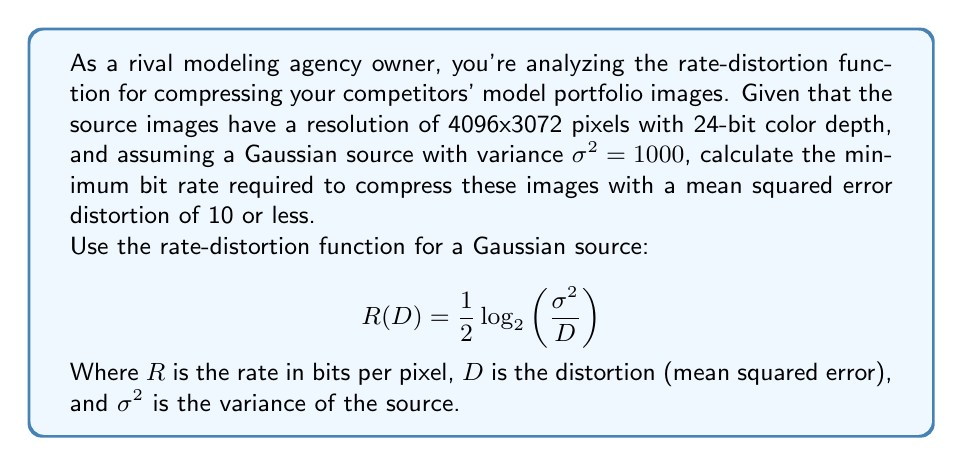What is the answer to this math problem? Let's approach this step-by-step:

1) We're given:
   - Resolution: 4096x3072 pixels
   - Color depth: 24 bits
   - Variance $\sigma^2 = 1000$
   - Desired distortion $D \leq 10$

2) The rate-distortion function for a Gaussian source is:

   $$R(D) = \frac{1}{2}\log_2\left(\frac{\sigma^2}{D}\right)$$

3) We want the minimum bit rate, so we'll use the maximum allowable distortion, $D = 10$:

   $$R(10) = \frac{1}{2}\log_2\left(\frac{1000}{10}\right)$$

4) Simplify:
   $$R(10) = \frac{1}{2}\log_2(100) = \frac{1}{2} \cdot 6.64385618977 \approx 3.32192809488$$

5) This gives us the rate in bits per pixel. To get the total number of bits, we need to multiply by the number of pixels:

   Total bits = $3.32192809488 \cdot 4096 \cdot 3072 = 41,811,550$ bits

6) Convert to megabytes:
   $41,811,550 \div (8 \cdot 1024 \cdot 1024) \approx 4.98$ MB

Note: The original uncompressed size would be:
$4096 \cdot 3072 \cdot 24 \div (8 \cdot 1024 \cdot 1024) = 36$ MB

So this compression reduces the file size by about 86%.
Answer: 4.98 MB 